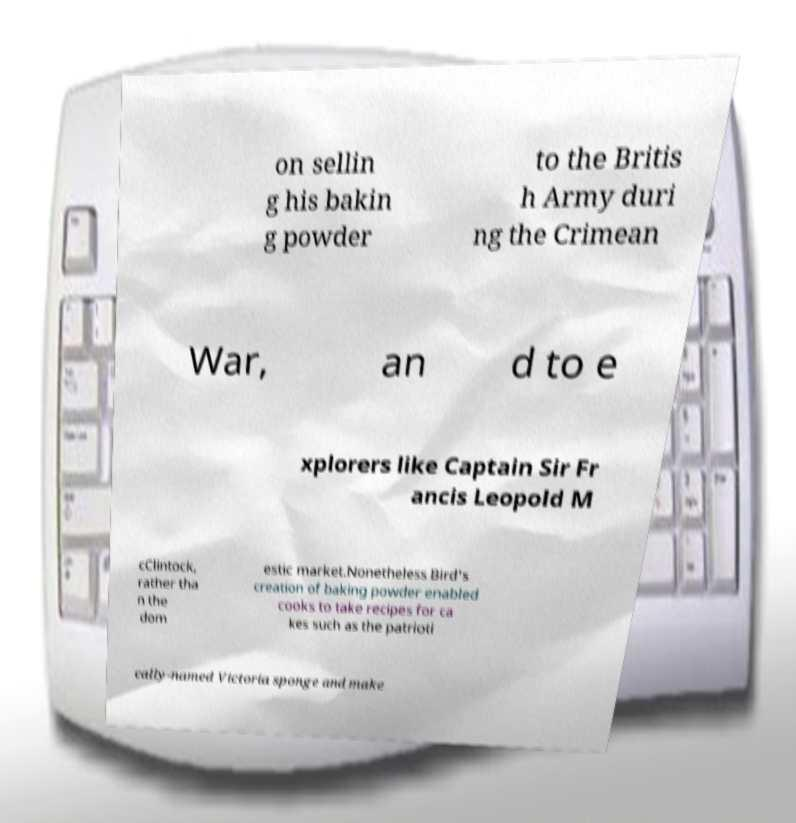There's text embedded in this image that I need extracted. Can you transcribe it verbatim? on sellin g his bakin g powder to the Britis h Army duri ng the Crimean War, an d to e xplorers like Captain Sir Fr ancis Leopold M cClintock, rather tha n the dom estic market.Nonetheless Bird's creation of baking powder enabled cooks to take recipes for ca kes such as the patrioti cally-named Victoria sponge and make 